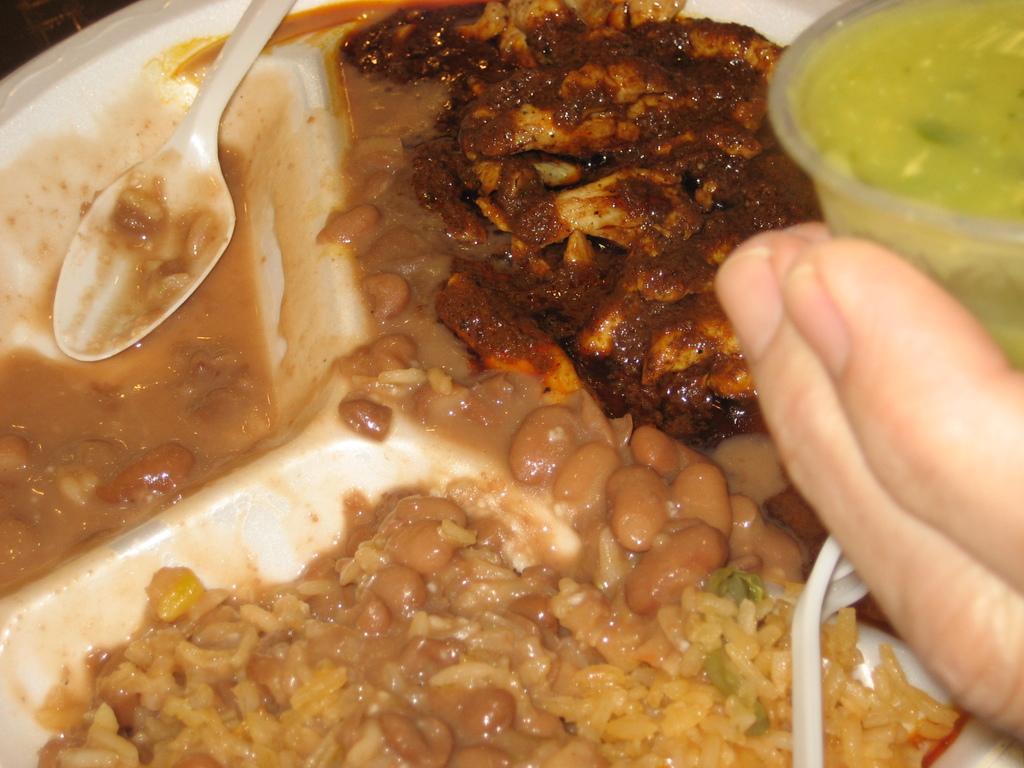Please provide a concise description of this image. In this picture there is a plate in the center of the image which contains food items in it and there is a hand on the right side of the image. 